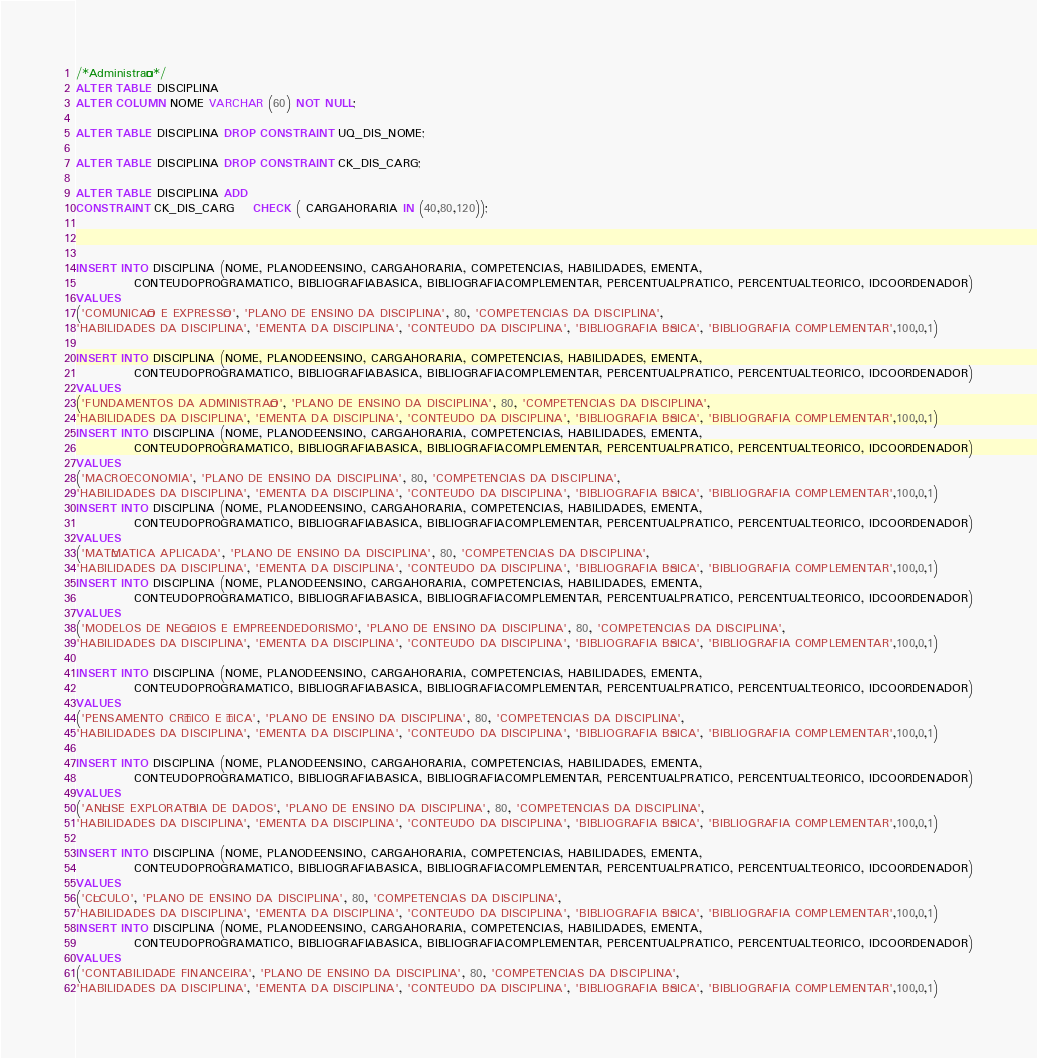<code> <loc_0><loc_0><loc_500><loc_500><_SQL_>/*Administração*/
ALTER TABLE DISCIPLINA 
ALTER COLUMN NOME VARCHAR (60) NOT NULL;

ALTER TABLE DISCIPLINA DROP CONSTRAINT UQ_DIS_NOME;

ALTER TABLE DISCIPLINA DROP CONSTRAINT CK_DIS_CARG;

ALTER TABLE DISCIPLINA ADD
CONSTRAINT CK_DIS_CARG	CHECK ( CARGAHORARIA IN (40,80,120));



INSERT INTO DISCIPLINA (NOME, PLANODEENSINO, CARGAHORARIA, COMPETENCIAS, HABILIDADES, EMENTA,
			CONTEUDOPROGRAMATICO, BIBLIOGRAFIABASICA, BIBLIOGRAFIACOMPLEMENTAR, PERCENTUALPRATICO, PERCENTUALTEORICO, IDCOORDENADOR)
VALUES
('COMUNICAÇÃO E EXPRESSÃO', 'PLANO DE ENSINO DA DISCIPLINA', 80, 'COMPETENCIAS DA DISCIPLINA',
'HABILIDADES DA DISCIPLINA', 'EMENTA DA DISCIPLINA', 'CONTEUDO DA DISCIPLINA', 'BIBLIOGRAFIA BÁSICA', 'BIBLIOGRAFIA COMPLEMENTAR',100,0,1)

INSERT INTO DISCIPLINA (NOME, PLANODEENSINO, CARGAHORARIA, COMPETENCIAS, HABILIDADES, EMENTA,
			CONTEUDOPROGRAMATICO, BIBLIOGRAFIABASICA, BIBLIOGRAFIACOMPLEMENTAR, PERCENTUALPRATICO, PERCENTUALTEORICO, IDCOORDENADOR)
VALUES
('FUNDAMENTOS DA ADMINISTRAÇÃO', 'PLANO DE ENSINO DA DISCIPLINA', 80, 'COMPETENCIAS DA DISCIPLINA',
'HABILIDADES DA DISCIPLINA', 'EMENTA DA DISCIPLINA', 'CONTEUDO DA DISCIPLINA', 'BIBLIOGRAFIA BÁSICA', 'BIBLIOGRAFIA COMPLEMENTAR',100,0,1)
INSERT INTO DISCIPLINA (NOME, PLANODEENSINO, CARGAHORARIA, COMPETENCIAS, HABILIDADES, EMENTA,
			CONTEUDOPROGRAMATICO, BIBLIOGRAFIABASICA, BIBLIOGRAFIACOMPLEMENTAR, PERCENTUALPRATICO, PERCENTUALTEORICO, IDCOORDENADOR)
VALUES
('MACROECONOMIA', 'PLANO DE ENSINO DA DISCIPLINA', 80, 'COMPETENCIAS DA DISCIPLINA',
'HABILIDADES DA DISCIPLINA', 'EMENTA DA DISCIPLINA', 'CONTEUDO DA DISCIPLINA', 'BIBLIOGRAFIA BÁSICA', 'BIBLIOGRAFIA COMPLEMENTAR',100,0,1)
INSERT INTO DISCIPLINA (NOME, PLANODEENSINO, CARGAHORARIA, COMPETENCIAS, HABILIDADES, EMENTA,
			CONTEUDOPROGRAMATICO, BIBLIOGRAFIABASICA, BIBLIOGRAFIACOMPLEMENTAR, PERCENTUALPRATICO, PERCENTUALTEORICO, IDCOORDENADOR)
VALUES
('MATÉMATICA APLICADA', 'PLANO DE ENSINO DA DISCIPLINA', 80, 'COMPETENCIAS DA DISCIPLINA',
'HABILIDADES DA DISCIPLINA', 'EMENTA DA DISCIPLINA', 'CONTEUDO DA DISCIPLINA', 'BIBLIOGRAFIA BÁSICA', 'BIBLIOGRAFIA COMPLEMENTAR',100,0,1)
INSERT INTO DISCIPLINA (NOME, PLANODEENSINO, CARGAHORARIA, COMPETENCIAS, HABILIDADES, EMENTA,
			CONTEUDOPROGRAMATICO, BIBLIOGRAFIABASICA, BIBLIOGRAFIACOMPLEMENTAR, PERCENTUALPRATICO, PERCENTUALTEORICO, IDCOORDENADOR)
VALUES
('MODELOS DE NEGÓCIOS E EMPREENDEDORISMO', 'PLANO DE ENSINO DA DISCIPLINA', 80, 'COMPETENCIAS DA DISCIPLINA',
'HABILIDADES DA DISCIPLINA', 'EMENTA DA DISCIPLINA', 'CONTEUDO DA DISCIPLINA', 'BIBLIOGRAFIA BÁSICA', 'BIBLIOGRAFIA COMPLEMENTAR',100,0,1)

INSERT INTO DISCIPLINA (NOME, PLANODEENSINO, CARGAHORARIA, COMPETENCIAS, HABILIDADES, EMENTA,
			CONTEUDOPROGRAMATICO, BIBLIOGRAFIABASICA, BIBLIOGRAFIACOMPLEMENTAR, PERCENTUALPRATICO, PERCENTUALTEORICO, IDCOORDENADOR)
VALUES
('PENSAMENTO CRÍTICO E ÉTICA', 'PLANO DE ENSINO DA DISCIPLINA', 80, 'COMPETENCIAS DA DISCIPLINA',
'HABILIDADES DA DISCIPLINA', 'EMENTA DA DISCIPLINA', 'CONTEUDO DA DISCIPLINA', 'BIBLIOGRAFIA BÁSICA', 'BIBLIOGRAFIA COMPLEMENTAR',100,0,1)

INSERT INTO DISCIPLINA (NOME, PLANODEENSINO, CARGAHORARIA, COMPETENCIAS, HABILIDADES, EMENTA,
			CONTEUDOPROGRAMATICO, BIBLIOGRAFIABASICA, BIBLIOGRAFIACOMPLEMENTAR, PERCENTUALPRATICO, PERCENTUALTEORICO, IDCOORDENADOR)
VALUES
('ANÁLISE EXPLORATÓRIA DE DADOS', 'PLANO DE ENSINO DA DISCIPLINA', 80, 'COMPETENCIAS DA DISCIPLINA',
'HABILIDADES DA DISCIPLINA', 'EMENTA DA DISCIPLINA', 'CONTEUDO DA DISCIPLINA', 'BIBLIOGRAFIA BÁSICA', 'BIBLIOGRAFIA COMPLEMENTAR',100,0,1)

INSERT INTO DISCIPLINA (NOME, PLANODEENSINO, CARGAHORARIA, COMPETENCIAS, HABILIDADES, EMENTA,
			CONTEUDOPROGRAMATICO, BIBLIOGRAFIABASICA, BIBLIOGRAFIACOMPLEMENTAR, PERCENTUALPRATICO, PERCENTUALTEORICO, IDCOORDENADOR)
VALUES
('CÁLCULO', 'PLANO DE ENSINO DA DISCIPLINA', 80, 'COMPETENCIAS DA DISCIPLINA',
'HABILIDADES DA DISCIPLINA', 'EMENTA DA DISCIPLINA', 'CONTEUDO DA DISCIPLINA', 'BIBLIOGRAFIA BÁSICA', 'BIBLIOGRAFIA COMPLEMENTAR',100,0,1)
INSERT INTO DISCIPLINA (NOME, PLANODEENSINO, CARGAHORARIA, COMPETENCIAS, HABILIDADES, EMENTA,
			CONTEUDOPROGRAMATICO, BIBLIOGRAFIABASICA, BIBLIOGRAFIACOMPLEMENTAR, PERCENTUALPRATICO, PERCENTUALTEORICO, IDCOORDENADOR)
VALUES
('CONTABILIDADE FINANCEIRA', 'PLANO DE ENSINO DA DISCIPLINA', 80, 'COMPETENCIAS DA DISCIPLINA',
'HABILIDADES DA DISCIPLINA', 'EMENTA DA DISCIPLINA', 'CONTEUDO DA DISCIPLINA', 'BIBLIOGRAFIA BÁSICA', 'BIBLIOGRAFIA COMPLEMENTAR',100,0,1)</code> 